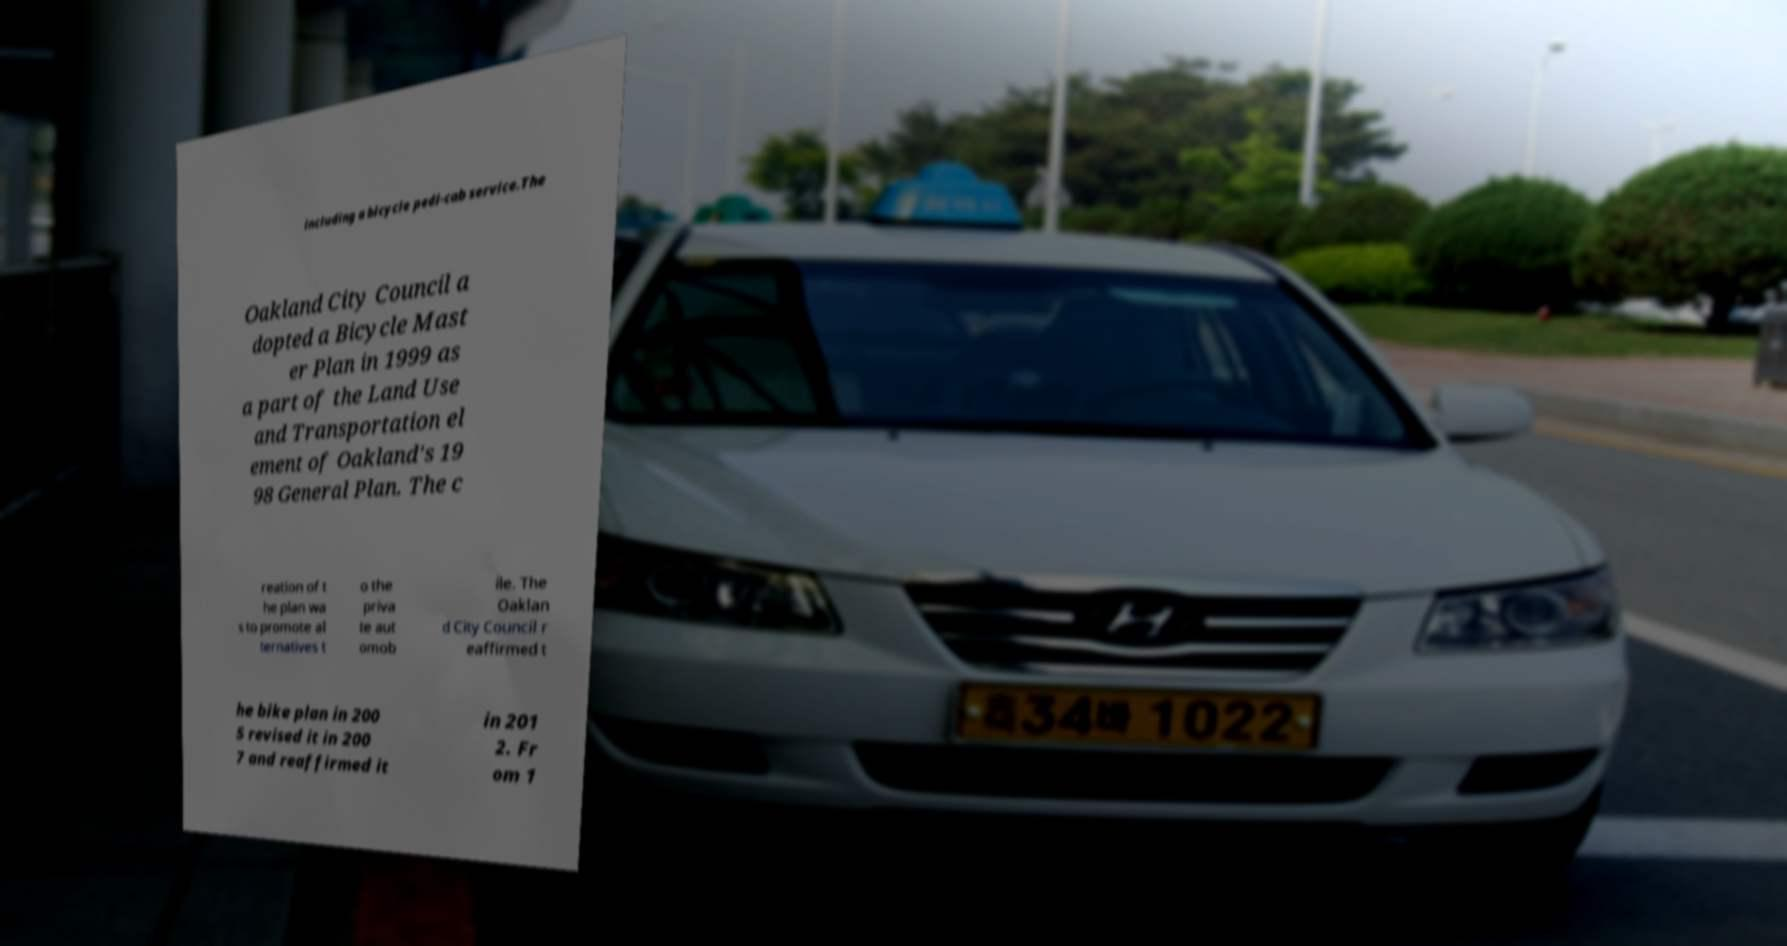Please identify and transcribe the text found in this image. including a bicycle pedi-cab service.The Oakland City Council a dopted a Bicycle Mast er Plan in 1999 as a part of the Land Use and Transportation el ement of Oakland's 19 98 General Plan. The c reation of t he plan wa s to promote al ternatives t o the priva te aut omob ile. The Oaklan d City Council r eaffirmed t he bike plan in 200 5 revised it in 200 7 and reaffirmed it in 201 2. Fr om 1 